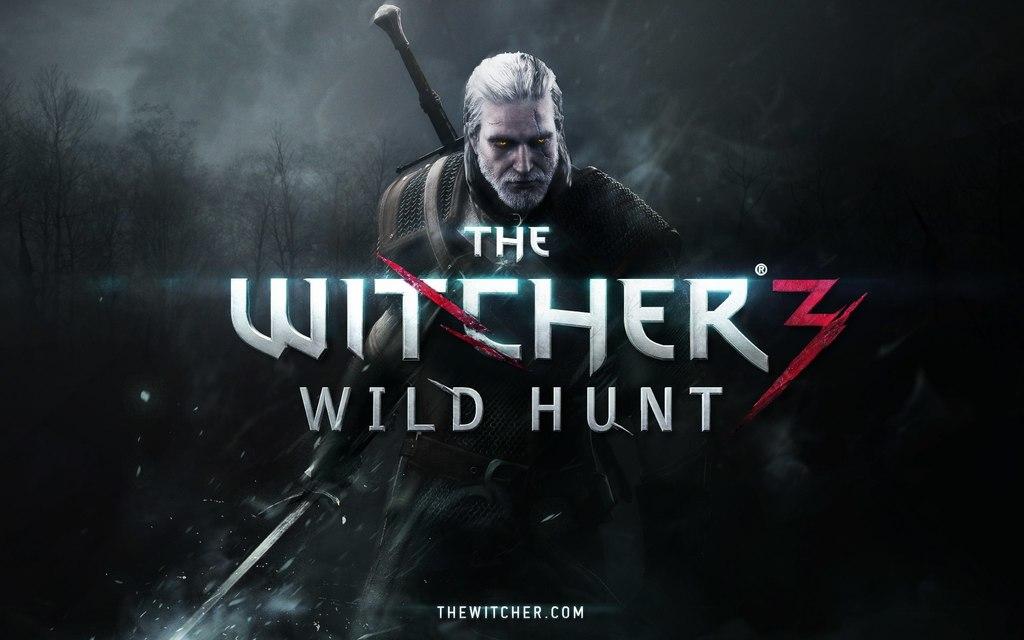What is the website for this game?
Your answer should be compact. Thewitcher.com. What's the name of the game?
Keep it short and to the point. The witcher 3 wild hunt. 